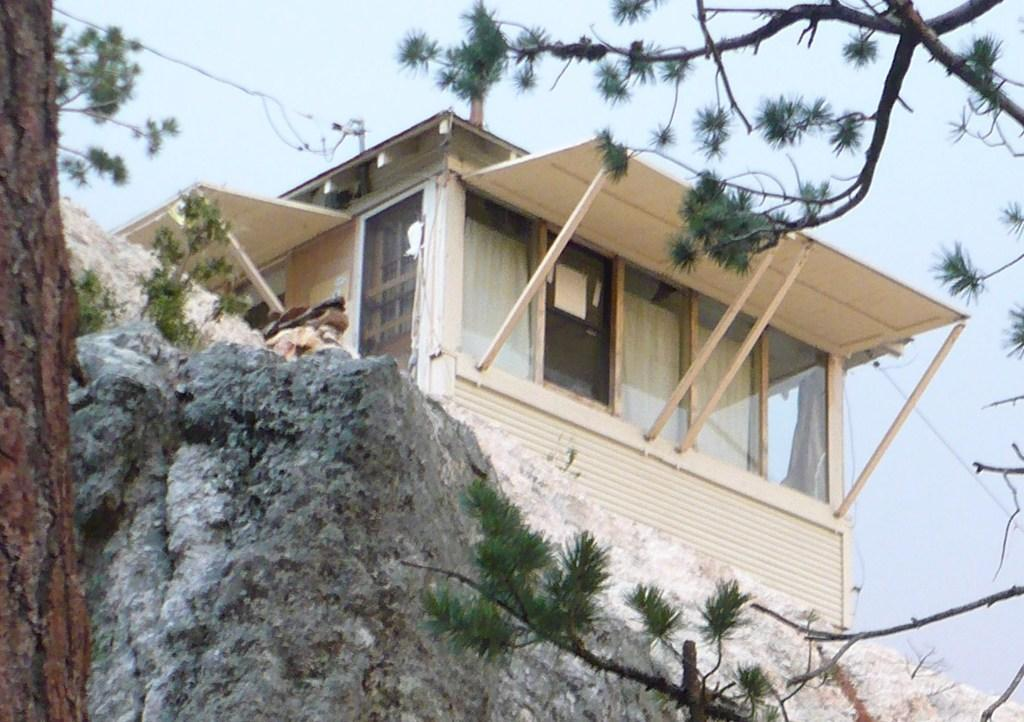What is the main structure in the image? There is a building on a rock in the image. What type of vegetation is present in the image? There are trees in front of the building in the image. What can be seen in the background of the image? The sky is visible in the background of the image. Where is the crowd gathered in the image? There is no crowd present in the image. What type of face can be seen on the building in the image? There is no face present on the building in the image. 